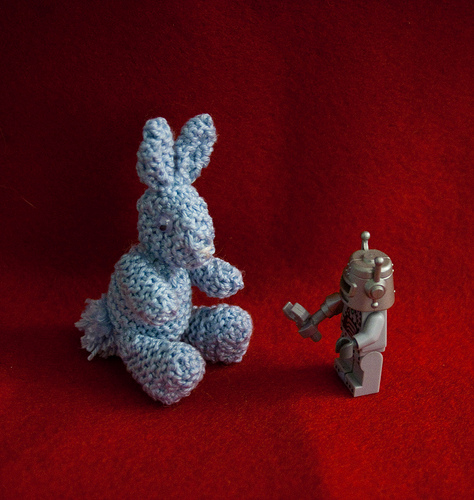<image>
Can you confirm if the blue bunny is to the right of the tan robot? No. The blue bunny is not to the right of the tan robot. The horizontal positioning shows a different relationship. 